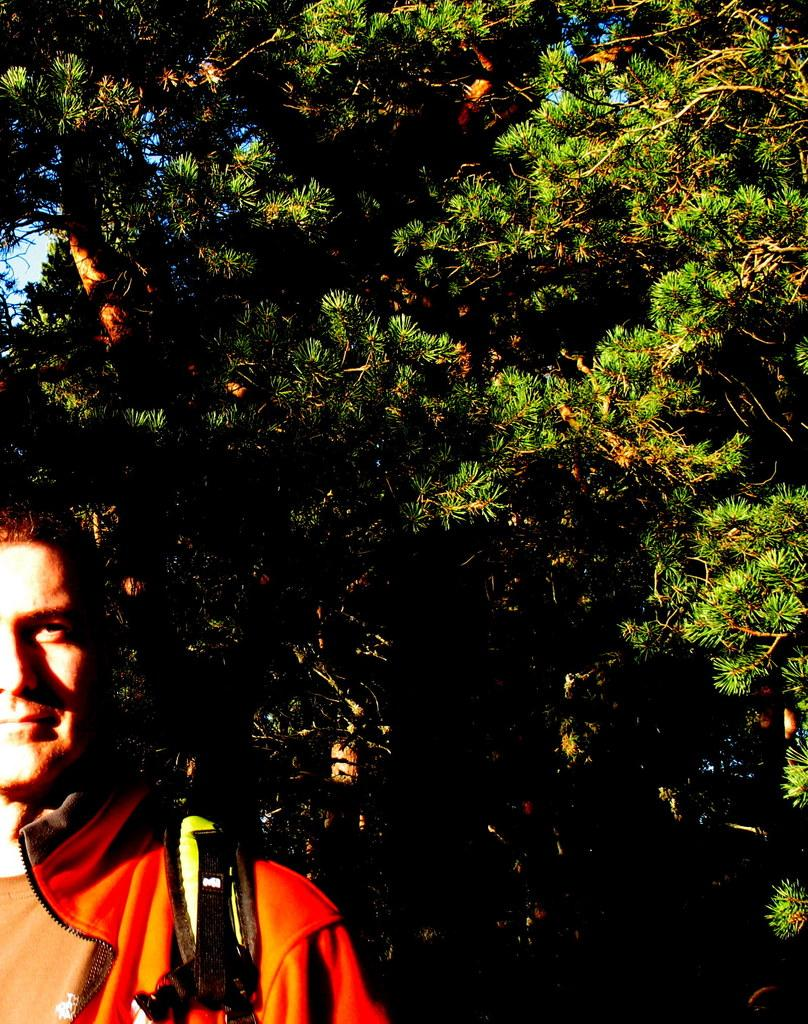Who or what is present in the image? There is a person in the image. Where is the person located in the image? The person is at the bottom right corner of the image. What is the person wearing in the image? The person appears to be wearing a bag. What can be seen in the background of the image? There are trees visible behind the person. How many cows are visible in the image? There are no cows present in the image; only a person and trees are visible. 